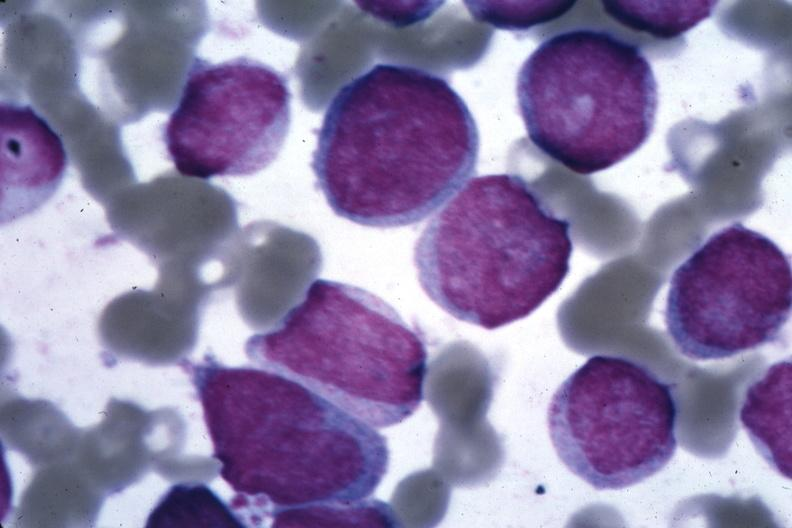s hematologic present?
Answer the question using a single word or phrase. Yes 